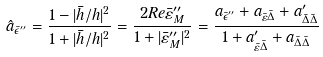Convert formula to latex. <formula><loc_0><loc_0><loc_500><loc_500>\hat { a } _ { \bar { \epsilon } ^ { \prime \prime } } = \frac { 1 - | \bar { h } / h | ^ { 2 } } { 1 + | \bar { h } / h | ^ { 2 } } = \frac { 2 R e \bar { \varepsilon } _ { M } ^ { \prime \prime } } { 1 + | \bar { \varepsilon } _ { M } ^ { \prime \prime } | ^ { 2 } } = \frac { a _ { \bar { \epsilon } ^ { \prime \prime } } + a _ { \bar { \varepsilon } \bar { \Delta } } + a ^ { \prime } _ { \bar { \Delta } \bar { \Delta } } } { 1 + a ^ { \prime } _ { \bar { \varepsilon } \bar { \Delta } } + a _ { \bar { \Delta } \bar { \Delta } } }</formula> 